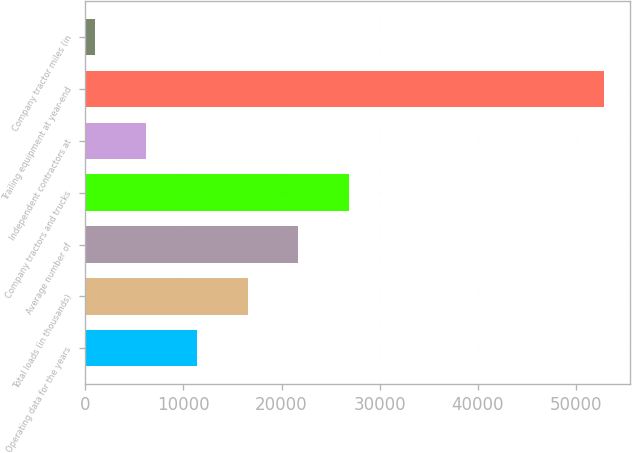Convert chart. <chart><loc_0><loc_0><loc_500><loc_500><bar_chart><fcel>Operating data for the years<fcel>Total loads (in thousands)<fcel>Average number of<fcel>Company tractors and trucks<fcel>Independent contractors at<fcel>Trailing equipment at year-end<fcel>Company tractor miles (in<nl><fcel>11348.2<fcel>16539.8<fcel>21731.4<fcel>26923<fcel>6156.6<fcel>52881<fcel>965<nl></chart> 